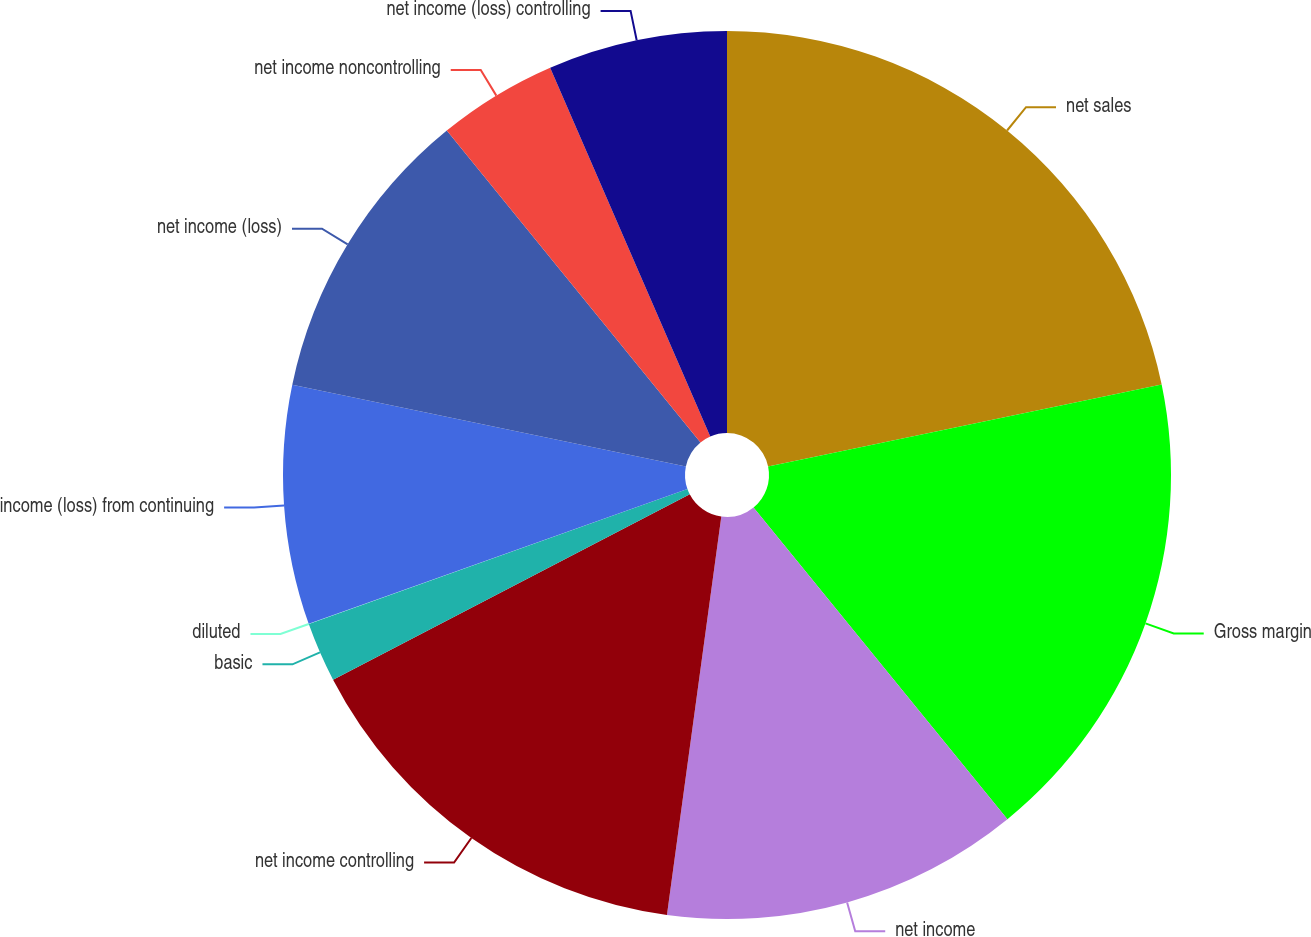Convert chart. <chart><loc_0><loc_0><loc_500><loc_500><pie_chart><fcel>net sales<fcel>Gross margin<fcel>net income<fcel>net income controlling<fcel>basic<fcel>diluted<fcel>income (loss) from continuing<fcel>net income (loss)<fcel>net income noncontrolling<fcel>net income (loss) controlling<nl><fcel>21.73%<fcel>17.39%<fcel>13.04%<fcel>15.21%<fcel>2.18%<fcel>0.01%<fcel>8.7%<fcel>10.87%<fcel>4.35%<fcel>6.52%<nl></chart> 